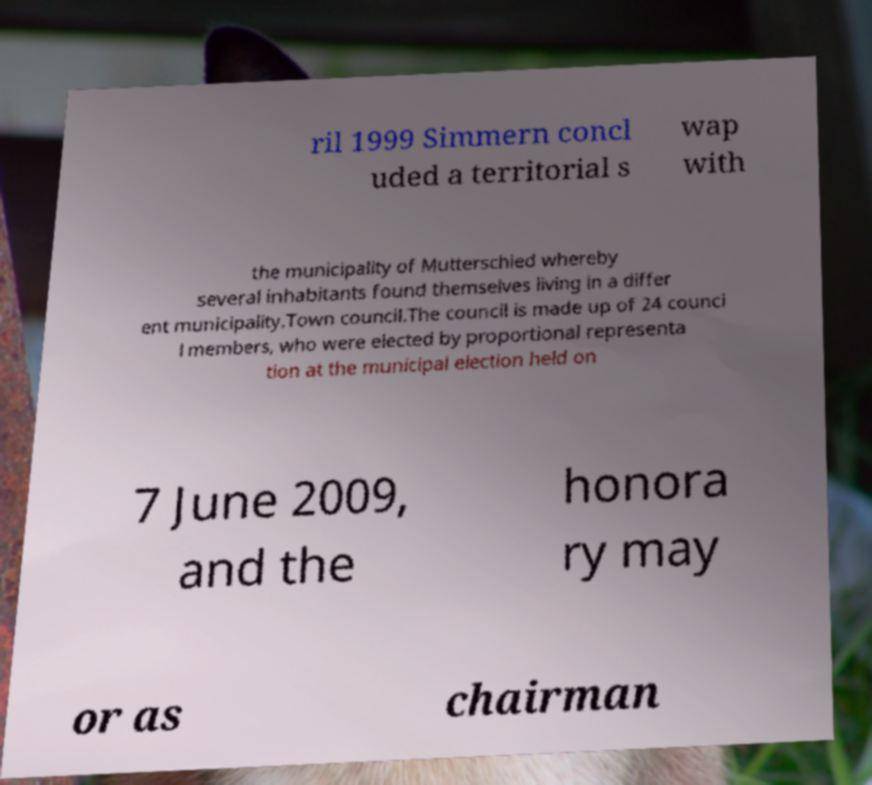Please read and relay the text visible in this image. What does it say? ril 1999 Simmern concl uded a territorial s wap with the municipality of Mutterschied whereby several inhabitants found themselves living in a differ ent municipality.Town council.The council is made up of 24 counci l members, who were elected by proportional representa tion at the municipal election held on 7 June 2009, and the honora ry may or as chairman 